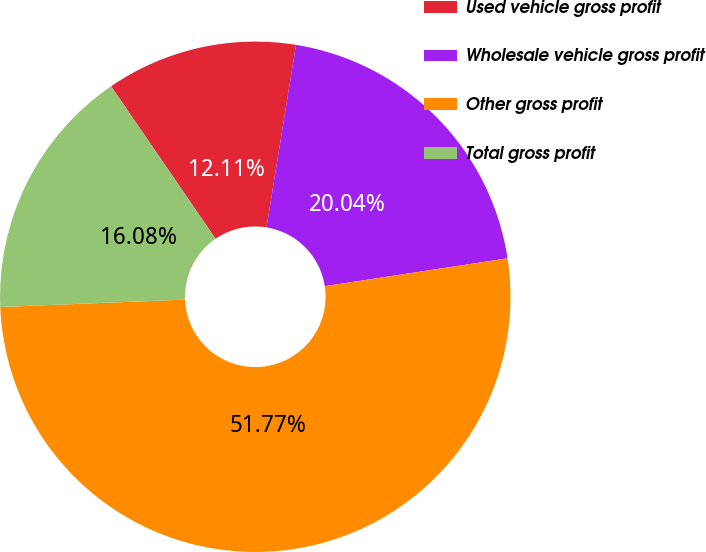Convert chart to OTSL. <chart><loc_0><loc_0><loc_500><loc_500><pie_chart><fcel>Used vehicle gross profit<fcel>Wholesale vehicle gross profit<fcel>Other gross profit<fcel>Total gross profit<nl><fcel>12.11%<fcel>20.04%<fcel>51.77%<fcel>16.08%<nl></chart> 